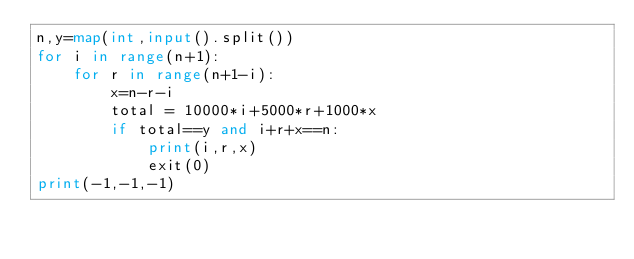<code> <loc_0><loc_0><loc_500><loc_500><_Python_>n,y=map(int,input().split())
for i in range(n+1):
    for r in range(n+1-i):
        x=n-r-i
        total = 10000*i+5000*r+1000*x
        if total==y and i+r+x==n:
            print(i,r,x)
            exit(0)
print(-1,-1,-1)
                </code> 